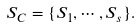<formula> <loc_0><loc_0><loc_500><loc_500>S _ { C } = \{ S _ { 1 } , \cdots , S _ { s } \} .</formula> 